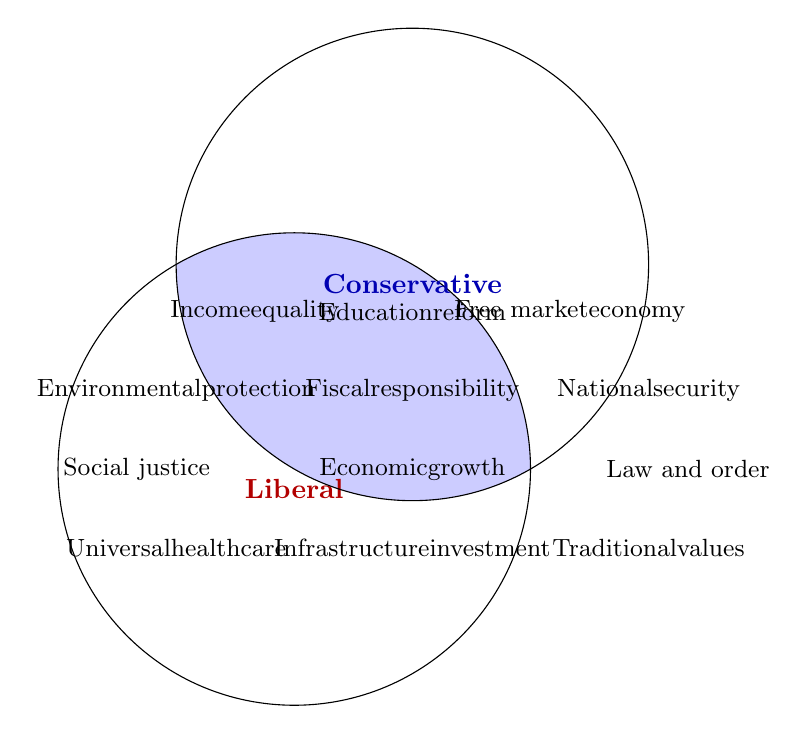Which policy priorities are unique to conservatives? Look at the blue circle labelled "Conservative" and list the elements outside the intersection with the red circle.
Answer: Law and order, National security, Traditional values, Free market economy, Second Amendment rights, Religious freedom, Tax cuts How many common policy priorities are there? Count the elements inside the intersection of both circles.
Answer: Four Is "National defense" a common priority or unique to either group? Check the area corresponding to the intersection and compare with the individual lists.
Answer: Common Which priority focuses on health for liberals? Look at the red circle and identify policy related to health.
Answer: Universal healthcare Between liberals and conservatives, who emphasizes "Social justice"? Check which group includes "Social justice".
Answer: Liberals What is the liberal stance on economic structure? Look at the liberal circle to find any policies related to economics.
Answer: Income equality How do conservatives view the economy differently from liberals? Compare elements in the conservative circle related to economics with those in the liberal circle.
Answer: Conservatives favor Free market economy How do liberal and conservative priorities overlap when it comes to policy advancement? Identify the shared terms in the intersection of both circles.
Answer: Economic growth, Fiscal responsibility, Infrastructure investment, Education reform 